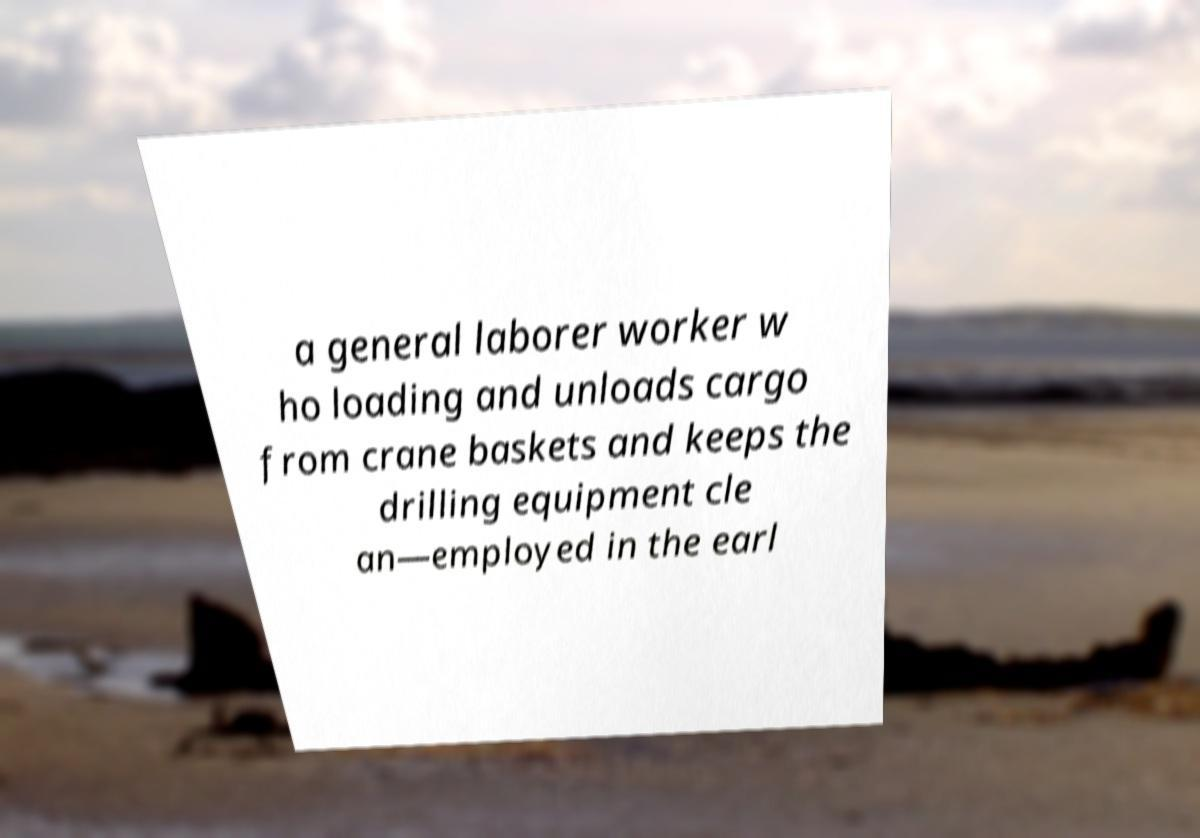I need the written content from this picture converted into text. Can you do that? a general laborer worker w ho loading and unloads cargo from crane baskets and keeps the drilling equipment cle an—employed in the earl 